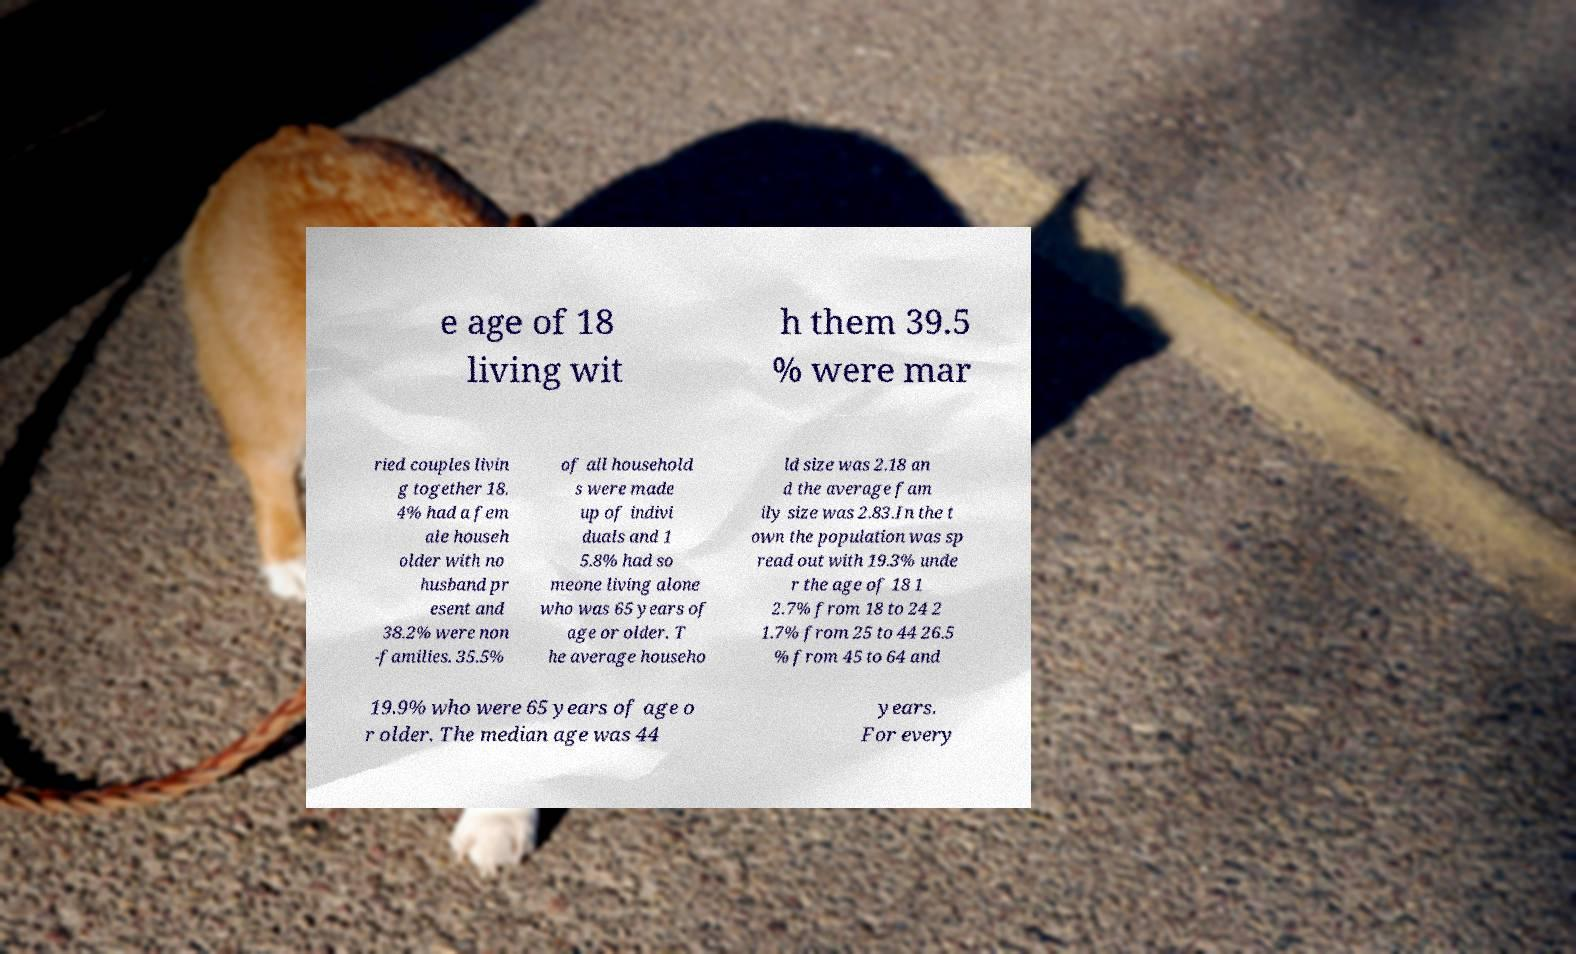Please read and relay the text visible in this image. What does it say? e age of 18 living wit h them 39.5 % were mar ried couples livin g together 18. 4% had a fem ale househ older with no husband pr esent and 38.2% were non -families. 35.5% of all household s were made up of indivi duals and 1 5.8% had so meone living alone who was 65 years of age or older. T he average househo ld size was 2.18 an d the average fam ily size was 2.83.In the t own the population was sp read out with 19.3% unde r the age of 18 1 2.7% from 18 to 24 2 1.7% from 25 to 44 26.5 % from 45 to 64 and 19.9% who were 65 years of age o r older. The median age was 44 years. For every 